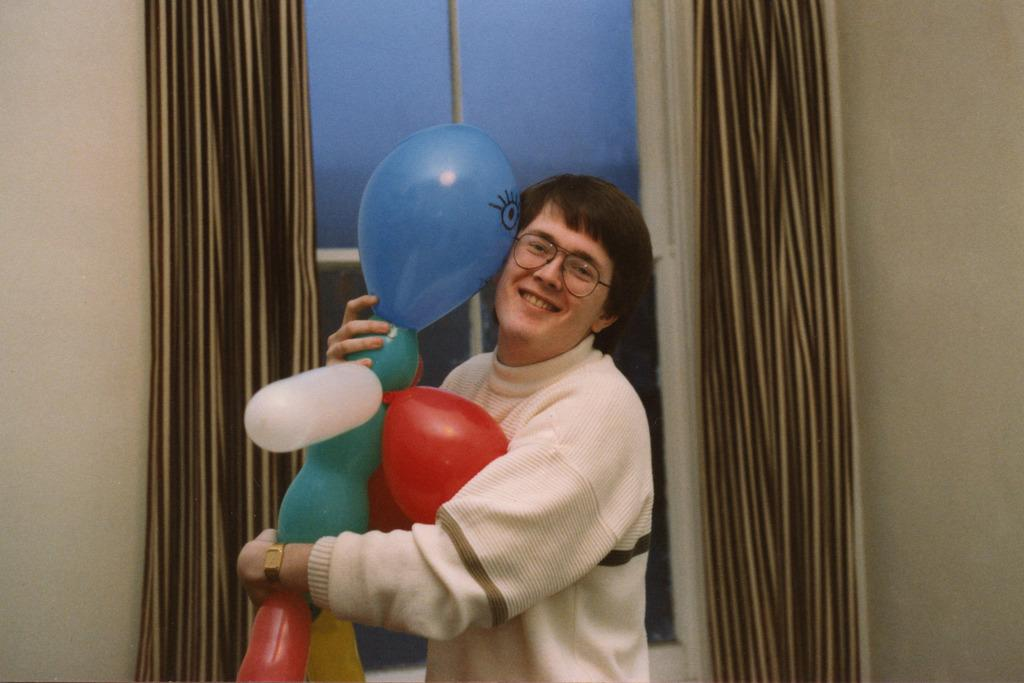What is the person in the image holding? The person is holding balloons in the image. Can you describe the balloons? The balloons are in different colors. What is the person wearing? The person is wearing a white dress. What can be seen in the background of the image? There is a curtain, a glass window, and a wall visible in the image. What type of quiver can be seen on the person's back in the image? There is no quiver present on the person's back in the image. Can you describe the snail crawling on the wall in the image? There is no snail present on the wall in the image. 